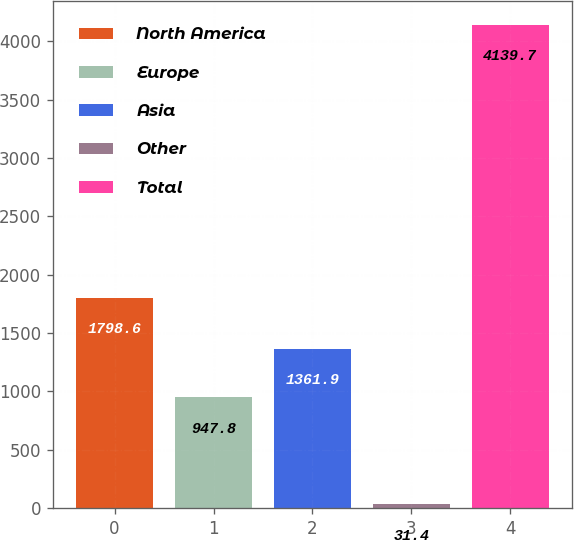<chart> <loc_0><loc_0><loc_500><loc_500><bar_chart><fcel>North America<fcel>Europe<fcel>Asia<fcel>Other<fcel>Total<nl><fcel>1798.6<fcel>947.8<fcel>1361.9<fcel>31.4<fcel>4139.7<nl></chart> 